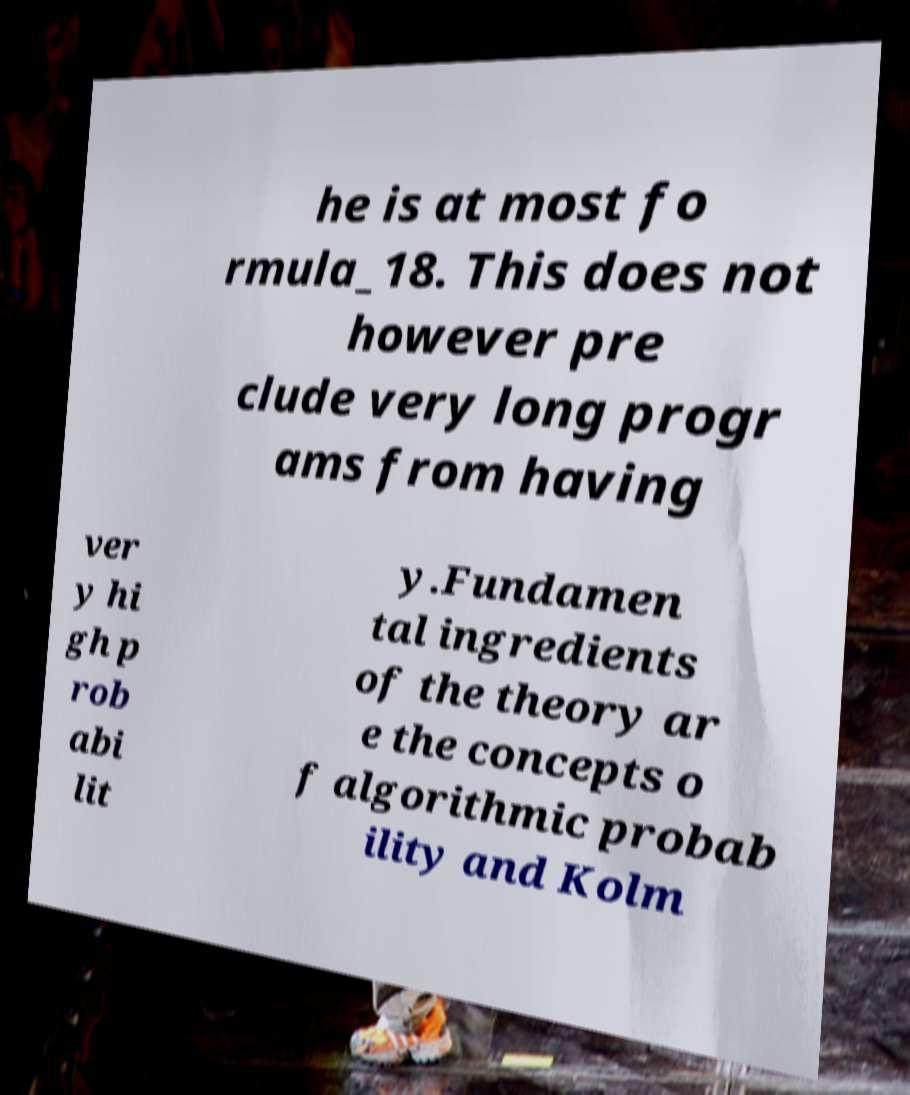Please identify and transcribe the text found in this image. he is at most fo rmula_18. This does not however pre clude very long progr ams from having ver y hi gh p rob abi lit y.Fundamen tal ingredients of the theory ar e the concepts o f algorithmic probab ility and Kolm 